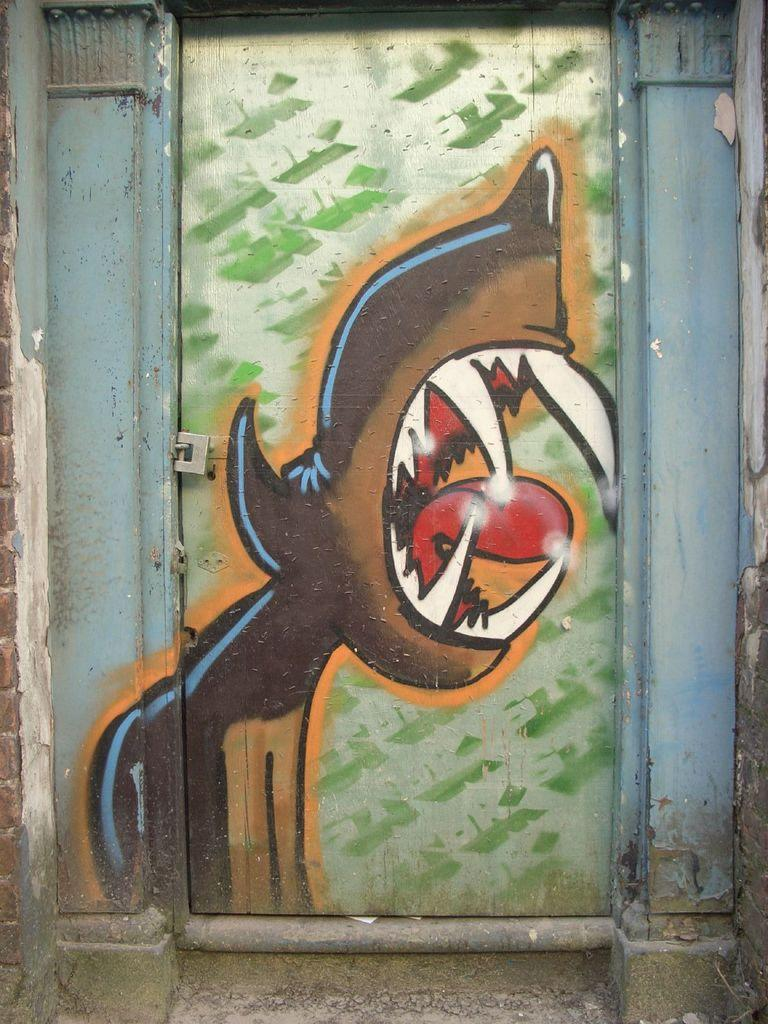What is depicted on the door in the image? There is a painting on a door in the image. How many lizards can be seen swimming in the sea in the image? There is no sea or lizards present in the image; it features a painting on a door. 